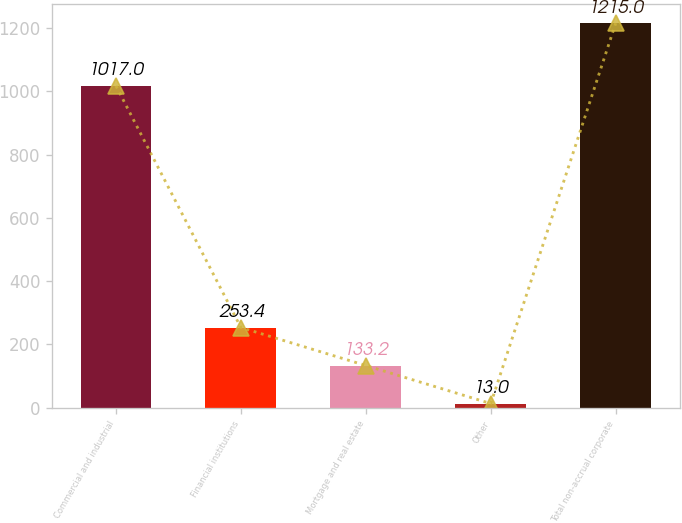<chart> <loc_0><loc_0><loc_500><loc_500><bar_chart><fcel>Commercial and industrial<fcel>Financial institutions<fcel>Mortgage and real estate<fcel>Other<fcel>Total non-accrual corporate<nl><fcel>1017<fcel>253.4<fcel>133.2<fcel>13<fcel>1215<nl></chart> 